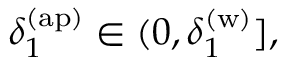<formula> <loc_0><loc_0><loc_500><loc_500>\delta _ { 1 } ^ { ( a p ) } \in ( 0 , \delta _ { 1 } ^ { ( w ) } ] ,</formula> 